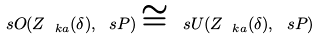Convert formula to latex. <formula><loc_0><loc_0><loc_500><loc_500>\ s O ( Z _ { \ k a } ( \delta ) , \ s P ) \cong \ s U ( Z _ { \ k a } ( \delta ) , \ s P )</formula> 